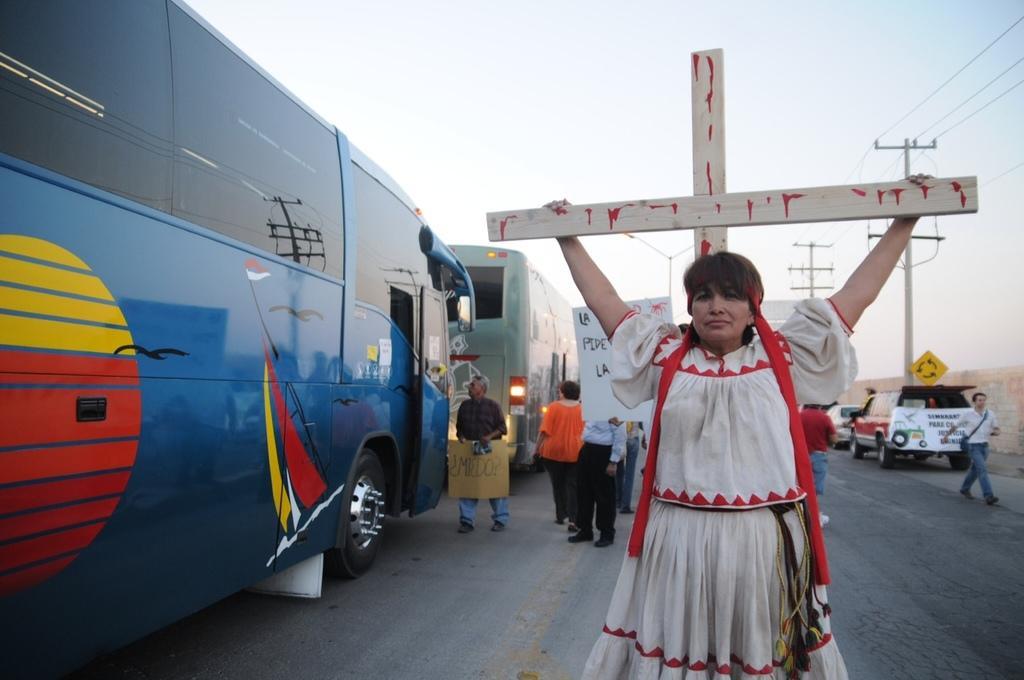How would you summarize this image in a sentence or two? This is the woman standing and holding a holy cross symbol in her hands. There are group of people standing. Here is a person walking. These are the vehicles on the road. I can see the current poles with the current wires. This is the sky. 